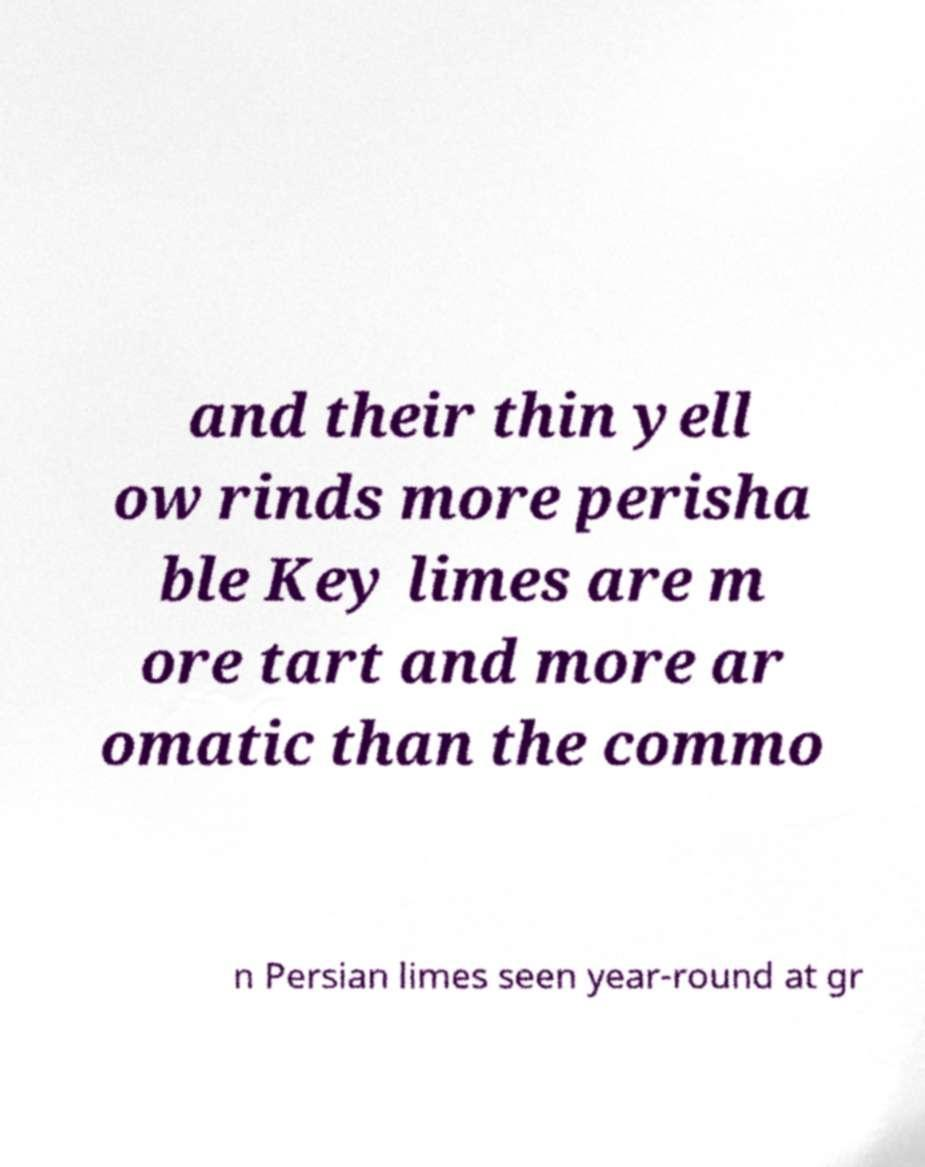Could you extract and type out the text from this image? and their thin yell ow rinds more perisha ble Key limes are m ore tart and more ar omatic than the commo n Persian limes seen year-round at gr 